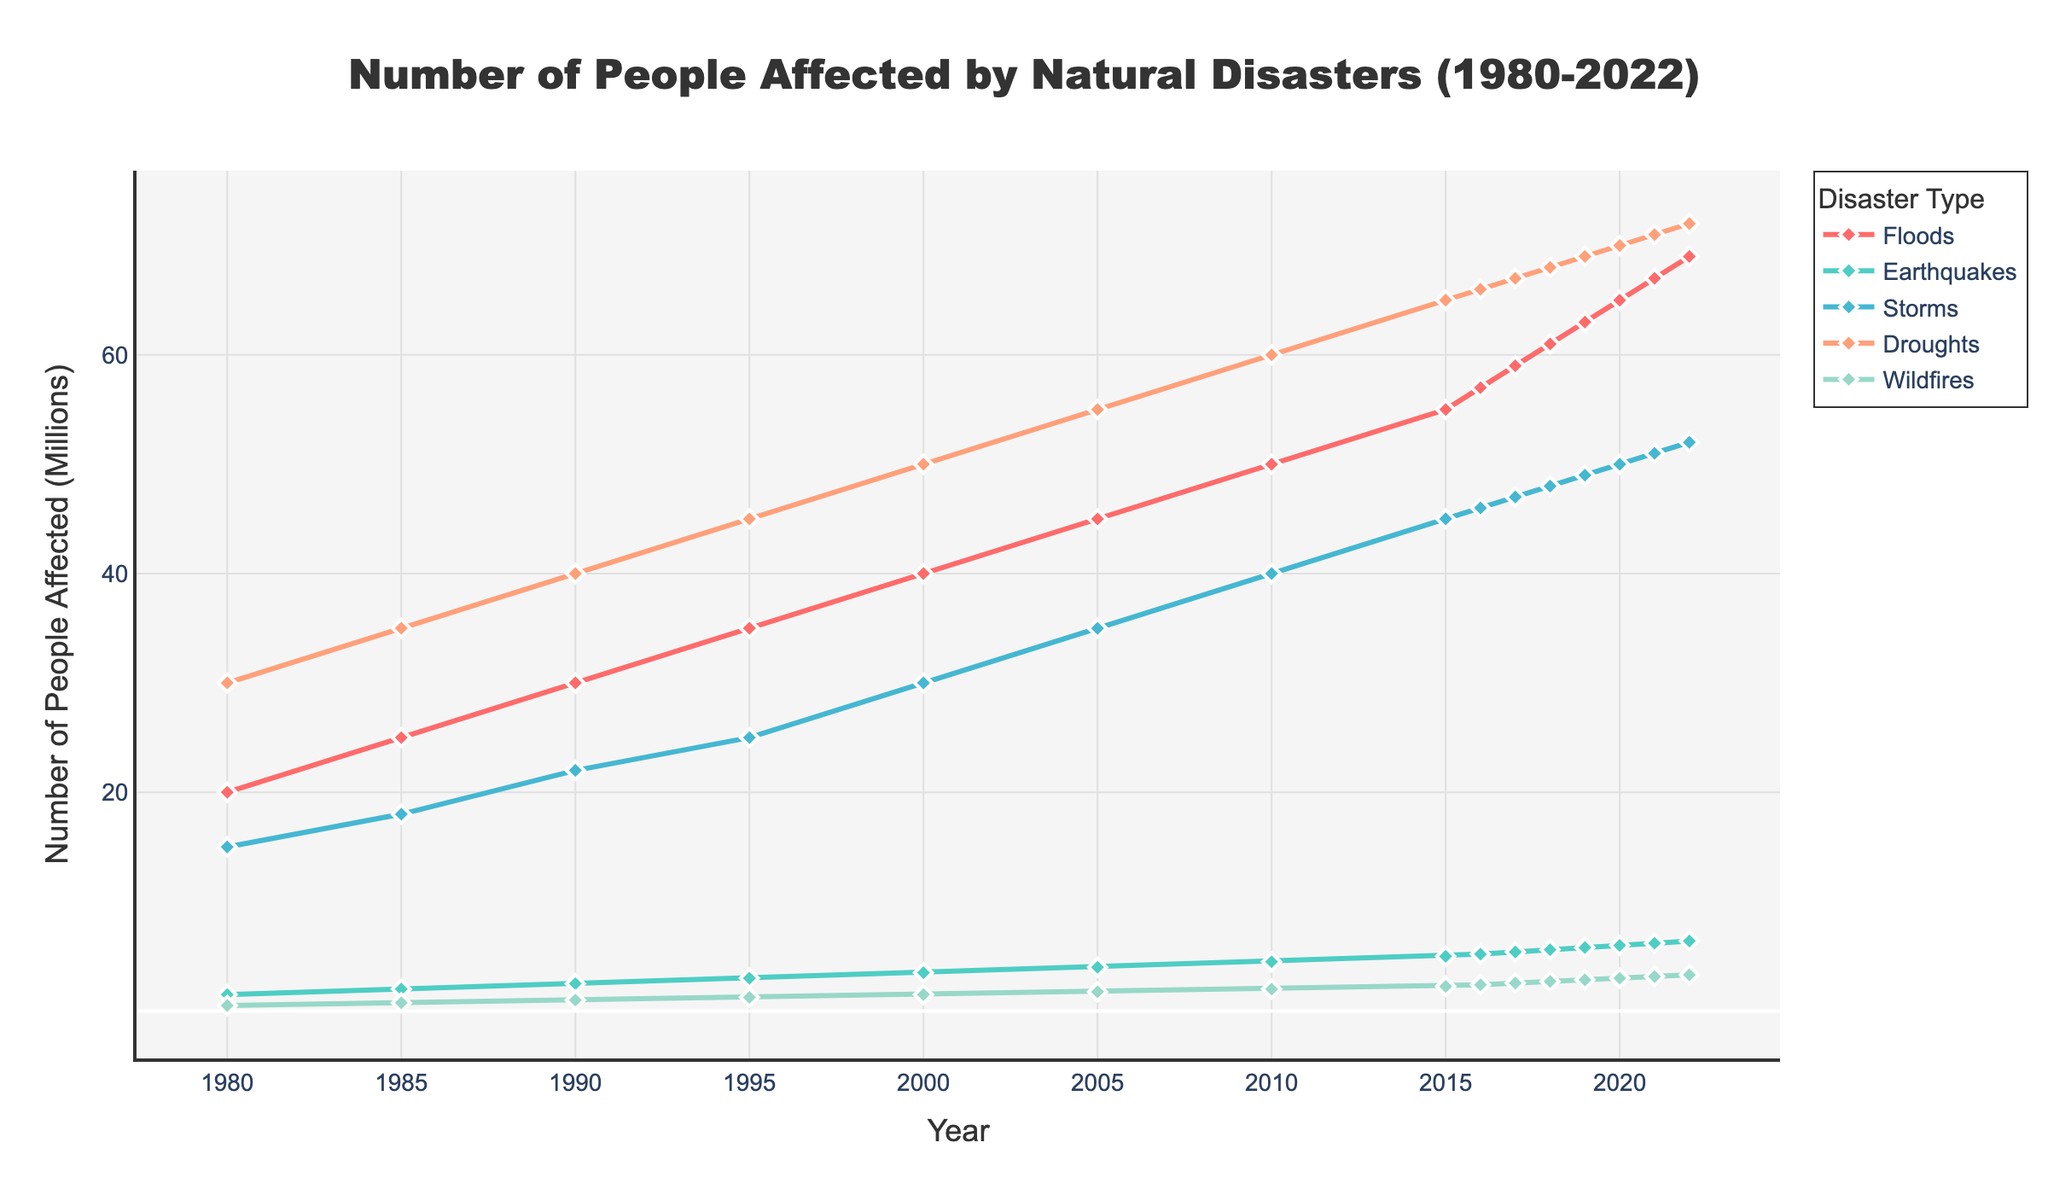Which disaster type had the highest number of people affected in 2022? Look at the year 2022 on the x-axis and compare the y-values (number of people affected) for each disaster type. The highest y-value corresponds to Droughts.
Answer: Droughts How has the number of people affected by floods changed from 1980 to 2022? Observe the line for Floods from 1980 to 2022. Note the y-values at the start and end points: 20000000 in 1980 and 69000000 in 2022, indicating an increase.
Answer: Increased In which year did the number of people affected by earthquakes first exceed 5 million? Examine the line for Earthquakes and identify the first data point above 5000000 on the y-axis, which is in 2015 with 5000000. Verify the next year data point: in 2016, 5200000.
Answer: 2016 Compare the rate of increase for people affected by storms and wildfires from 2000 to 2020. Which increased faster? Analyze the slopes of the lines representing Storms and Wildfires between 2000 (30000000 for Storms and 1500000 for Wildfires) and 2020 (50000000 for Storms and 3000000 for Wildfires). Calculate the rate of increase: (50000000-30000000)/20 = 1000000 per year for Storms, and (3000000-1500000)/20 = 75000 per year for Wildfires.
Answer: Storms What was the average number of people affected by droughts over the decades (1980s, 1990s, 2000s, 2010s)? Determine the number of people affected by droughts for each decade and calculate the average: 1980s: (30000000, 35000000, 40000000) = 35000000, 1990s: (45000000, 50000000) = 45000000, 2000s: (55000000, 60000000) = 57500000, 2010s: (66000000, 67000000, 68000000, 69000000) = 67500000. The overall average is (35000000 + 45000000 + 57500000 + 67500000)/4 = 51250000.
Answer: 51250000 Between which consecutive years did wildfires show the most significant increase in affected people, and by how much? Identify the two consecutive years with the largest increase in the line for Wildfires by comparing differences in their y-values from one year to the next. Notably between 2019 (2850000) and 2020 (3000000). Calculate the difference: 3000000 - 2850000 = 150000.
Answer: 2019-2020, 150000 Which disaster type consistently affected the least number of people throughout the period from 1980 to 2022? By examining all the lines, Wildfires consistently have the highest minimum y-values compared to other disaster types.
Answer: Wildfires What is the total number of people affected by earthquakes from 1980 to 2022? Sum the numbers for Earthquakes from each year: 1500000 + 2000000 + 2500000 + 3000000 + 3500000 + 4000000 + 4500000 + 5000000 + 5200000 + 5400000 + 5600000 + 5800000 + 6000000 + 6200000 + 6400000 = 71500000.
Answer: 71500000 